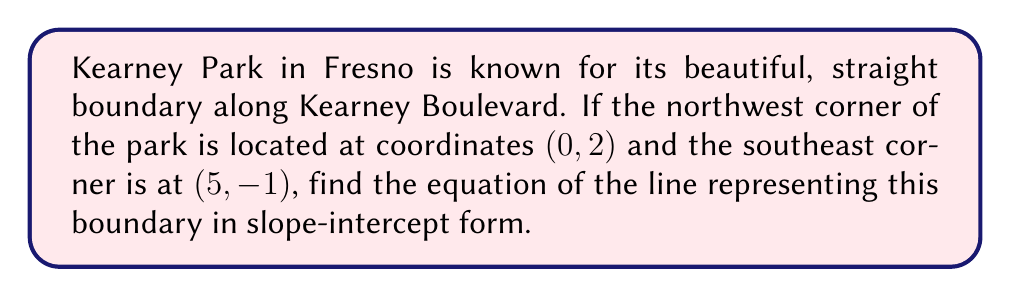Solve this math problem. To find the equation of the line representing Kearney Park's boundary, we'll follow these steps:

1) First, let's identify our two points:
   Point 1 (northwest corner): $(x_1, y_1) = (0, 2)$
   Point 2 (southeast corner): $(x_2, y_2) = (5, -1)$

2) We can find the slope of the line using the slope formula:
   $$m = \frac{y_2 - y_1}{x_2 - x_1} = \frac{-1 - 2}{5 - 0} = \frac{-3}{5} = -0.6$$

3) Now that we have the slope, we can use the point-slope form of a line:
   $y - y_1 = m(x - x_1)$

4) Let's use the northwest corner point (0, 2):
   $y - 2 = -0.6(x - 0)$

5) Simplify:
   $y - 2 = -0.6x$

6) Add 2 to both sides to get the equation in slope-intercept form $(y = mx + b)$:
   $y = -0.6x + 2$

This equation represents the straight boundary of Kearney Park along Kearney Boulevard.
Answer: $y = -0.6x + 2$ 